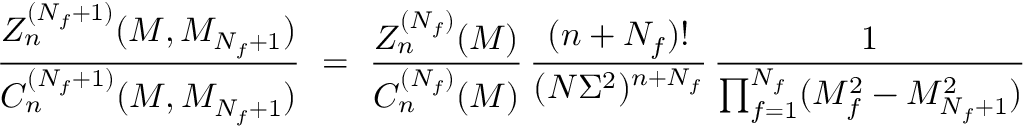Convert formula to latex. <formula><loc_0><loc_0><loc_500><loc_500>\frac { Z _ { n } ^ { ( N _ { f } + 1 ) } ( M , M _ { N _ { f } + 1 } ) } { C _ { n } ^ { ( N _ { f } + 1 ) } ( M , M _ { N _ { f } + 1 } ) } \ = \ \frac { Z _ { n } ^ { ( N _ { f } ) } ( M ) } { C _ { n } ^ { ( N _ { f } ) } ( M ) } \, \frac { ( n + N _ { f } ) ! } { ( N \Sigma ^ { 2 } ) ^ { n + N _ { f } } } \, \frac { 1 } { \prod _ { f = 1 } ^ { N _ { f } } ( M _ { f } ^ { 2 } - M _ { N _ { f } + 1 } ^ { 2 } ) }</formula> 